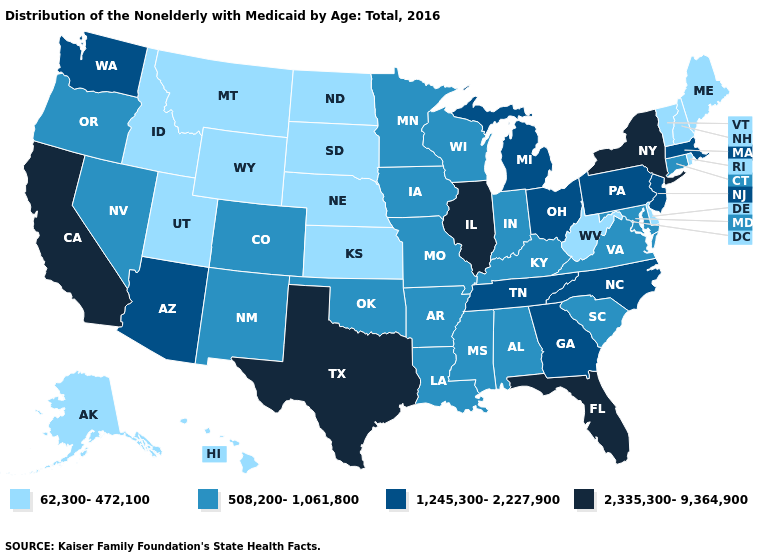Among the states that border Indiana , does Michigan have the lowest value?
Keep it brief. No. Among the states that border Maryland , does Pennsylvania have the highest value?
Be succinct. Yes. What is the value of Illinois?
Quick response, please. 2,335,300-9,364,900. What is the value of New Mexico?
Write a very short answer. 508,200-1,061,800. Which states have the highest value in the USA?
Short answer required. California, Florida, Illinois, New York, Texas. What is the lowest value in the USA?
Give a very brief answer. 62,300-472,100. What is the lowest value in states that border North Carolina?
Give a very brief answer. 508,200-1,061,800. Name the states that have a value in the range 2,335,300-9,364,900?
Write a very short answer. California, Florida, Illinois, New York, Texas. What is the lowest value in the USA?
Answer briefly. 62,300-472,100. Name the states that have a value in the range 1,245,300-2,227,900?
Concise answer only. Arizona, Georgia, Massachusetts, Michigan, New Jersey, North Carolina, Ohio, Pennsylvania, Tennessee, Washington. Name the states that have a value in the range 508,200-1,061,800?
Write a very short answer. Alabama, Arkansas, Colorado, Connecticut, Indiana, Iowa, Kentucky, Louisiana, Maryland, Minnesota, Mississippi, Missouri, Nevada, New Mexico, Oklahoma, Oregon, South Carolina, Virginia, Wisconsin. Name the states that have a value in the range 508,200-1,061,800?
Give a very brief answer. Alabama, Arkansas, Colorado, Connecticut, Indiana, Iowa, Kentucky, Louisiana, Maryland, Minnesota, Mississippi, Missouri, Nevada, New Mexico, Oklahoma, Oregon, South Carolina, Virginia, Wisconsin. Which states have the highest value in the USA?
Concise answer only. California, Florida, Illinois, New York, Texas. What is the value of Pennsylvania?
Be succinct. 1,245,300-2,227,900. 